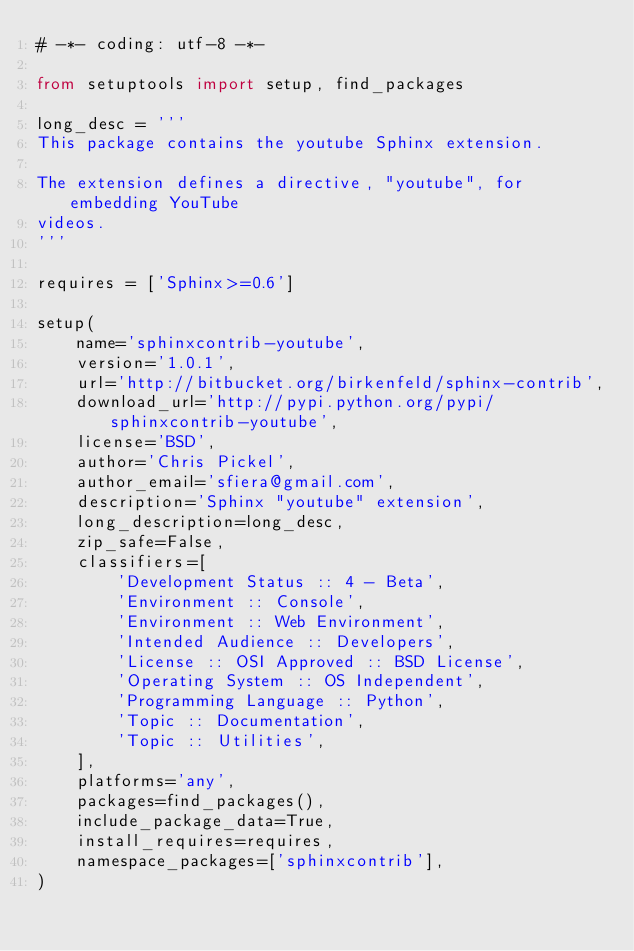Convert code to text. <code><loc_0><loc_0><loc_500><loc_500><_Python_># -*- coding: utf-8 -*-

from setuptools import setup, find_packages

long_desc = '''
This package contains the youtube Sphinx extension.

The extension defines a directive, "youtube", for embedding YouTube
videos.
'''

requires = ['Sphinx>=0.6']

setup(
    name='sphinxcontrib-youtube',
    version='1.0.1',
    url='http://bitbucket.org/birkenfeld/sphinx-contrib',
    download_url='http://pypi.python.org/pypi/sphinxcontrib-youtube',
    license='BSD',
    author='Chris Pickel',
    author_email='sfiera@gmail.com',
    description='Sphinx "youtube" extension',
    long_description=long_desc,
    zip_safe=False,
    classifiers=[
        'Development Status :: 4 - Beta',
        'Environment :: Console',
        'Environment :: Web Environment',
        'Intended Audience :: Developers',
        'License :: OSI Approved :: BSD License',
        'Operating System :: OS Independent',
        'Programming Language :: Python',
        'Topic :: Documentation',
        'Topic :: Utilities',
    ],
    platforms='any',
    packages=find_packages(),
    include_package_data=True,
    install_requires=requires,
    namespace_packages=['sphinxcontrib'],
)
</code> 